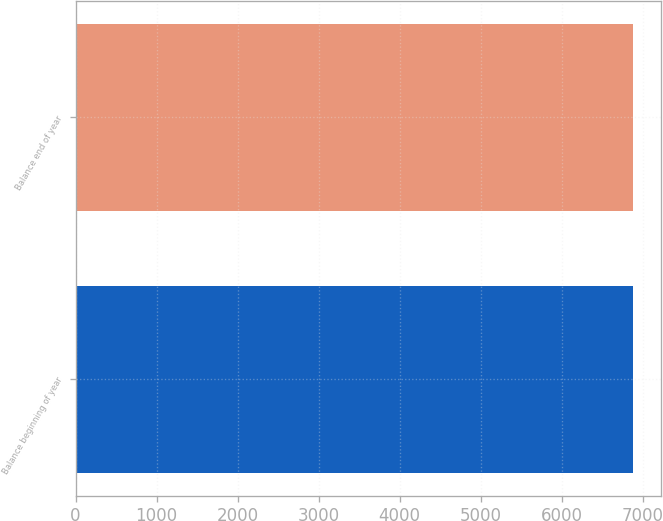Convert chart to OTSL. <chart><loc_0><loc_0><loc_500><loc_500><bar_chart><fcel>Balance beginning of year<fcel>Balance end of year<nl><fcel>6878<fcel>6878.1<nl></chart> 